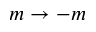<formula> <loc_0><loc_0><loc_500><loc_500>m \rightarrow - m</formula> 